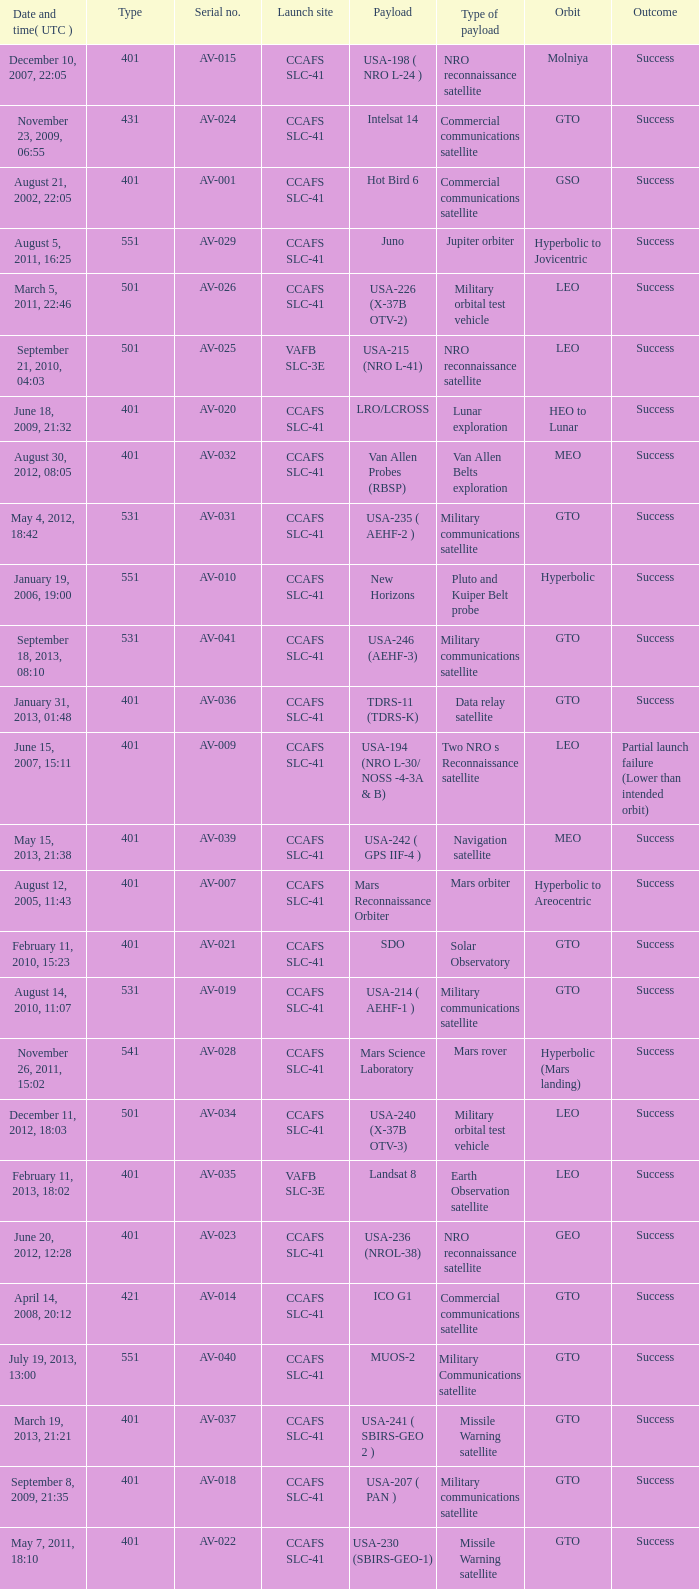What payload was on November 26, 2011, 15:02? Mars rover. 